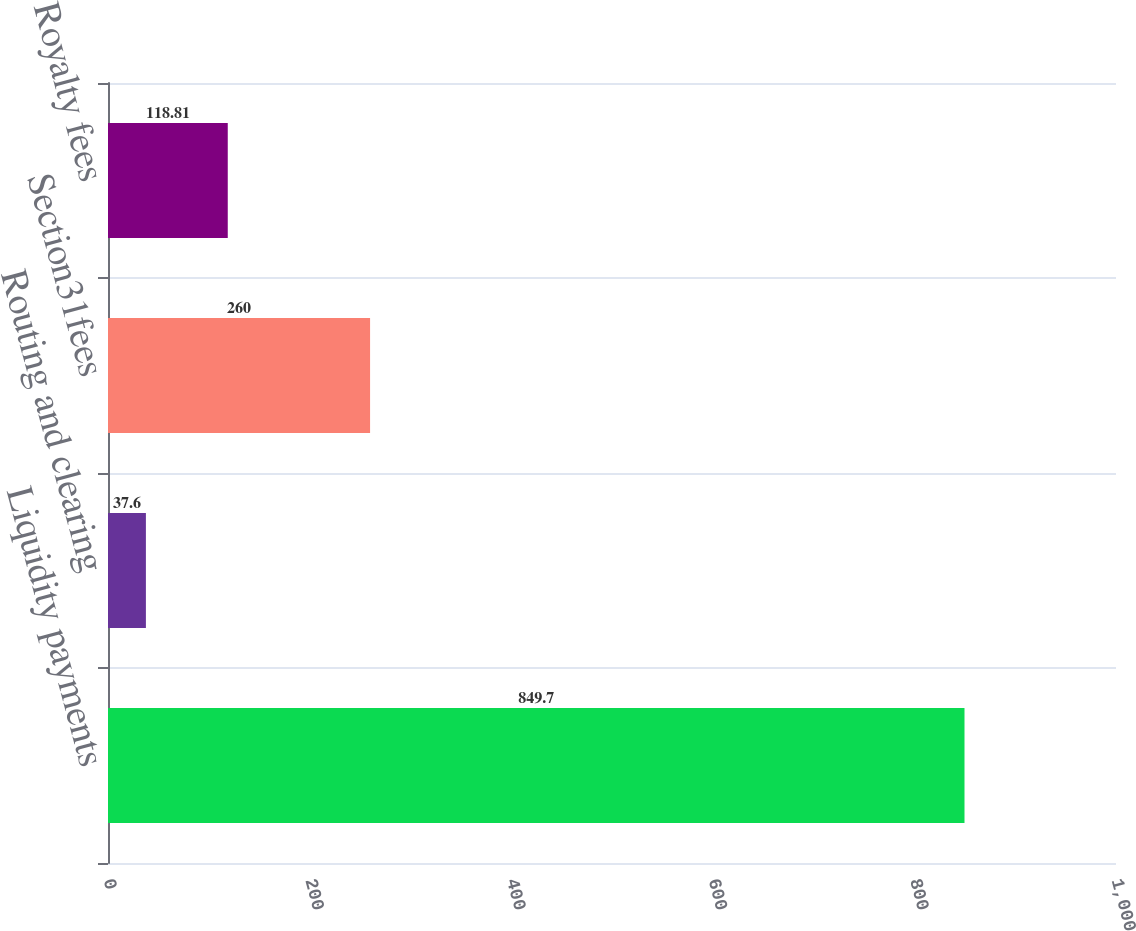Convert chart to OTSL. <chart><loc_0><loc_0><loc_500><loc_500><bar_chart><fcel>Liquidity payments<fcel>Routing and clearing<fcel>Section31fees<fcel>Royalty fees<nl><fcel>849.7<fcel>37.6<fcel>260<fcel>118.81<nl></chart> 